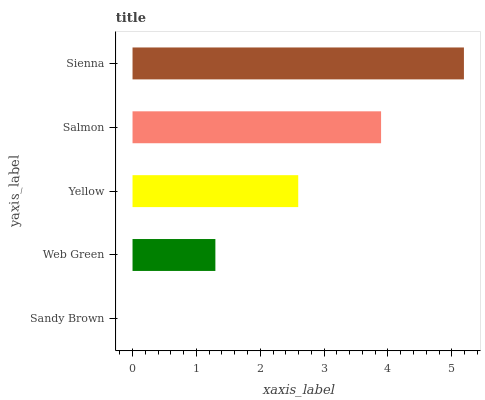Is Sandy Brown the minimum?
Answer yes or no. Yes. Is Sienna the maximum?
Answer yes or no. Yes. Is Web Green the minimum?
Answer yes or no. No. Is Web Green the maximum?
Answer yes or no. No. Is Web Green greater than Sandy Brown?
Answer yes or no. Yes. Is Sandy Brown less than Web Green?
Answer yes or no. Yes. Is Sandy Brown greater than Web Green?
Answer yes or no. No. Is Web Green less than Sandy Brown?
Answer yes or no. No. Is Yellow the high median?
Answer yes or no. Yes. Is Yellow the low median?
Answer yes or no. Yes. Is Sienna the high median?
Answer yes or no. No. Is Salmon the low median?
Answer yes or no. No. 